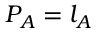<formula> <loc_0><loc_0><loc_500><loc_500>P _ { A } = l _ { A }</formula> 